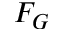<formula> <loc_0><loc_0><loc_500><loc_500>F _ { G }</formula> 